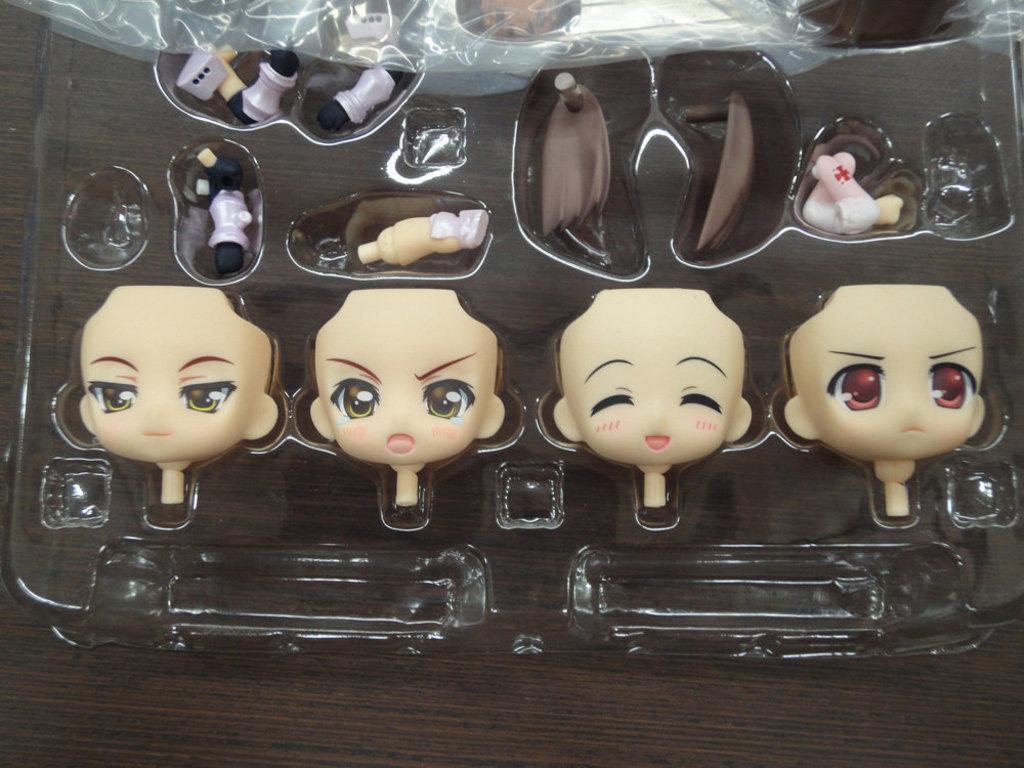Could you give a brief overview of what you see in this image? In this picture there are parts of the toys in the box. At the bottom it might be a table. 